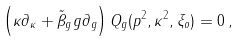<formula> <loc_0><loc_0><loc_500><loc_500>\left ( \kappa \partial _ { \kappa } + \tilde { \beta } _ { g } g \partial _ { g } \right ) Q _ { g } ( p ^ { 2 } , \kappa ^ { 2 } , \xi _ { o } ) = 0 \, ,</formula> 